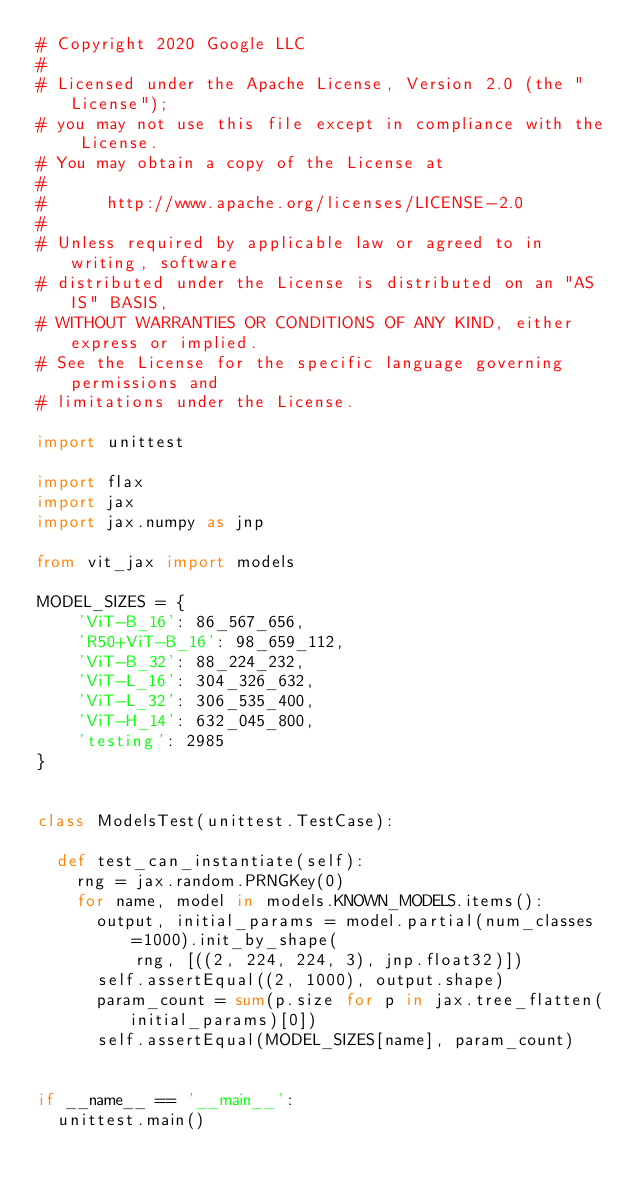<code> <loc_0><loc_0><loc_500><loc_500><_Python_># Copyright 2020 Google LLC
#
# Licensed under the Apache License, Version 2.0 (the "License");
# you may not use this file except in compliance with the License.
# You may obtain a copy of the License at
#
#      http://www.apache.org/licenses/LICENSE-2.0
#
# Unless required by applicable law or agreed to in writing, software
# distributed under the License is distributed on an "AS IS" BASIS,
# WITHOUT WARRANTIES OR CONDITIONS OF ANY KIND, either express or implied.
# See the License for the specific language governing permissions and
# limitations under the License.

import unittest

import flax
import jax
import jax.numpy as jnp

from vit_jax import models

MODEL_SIZES = {
    'ViT-B_16': 86_567_656,
    'R50+ViT-B_16': 98_659_112,
    'ViT-B_32': 88_224_232,
    'ViT-L_16': 304_326_632,
    'ViT-L_32': 306_535_400,
    'ViT-H_14': 632_045_800,
    'testing': 2985
}


class ModelsTest(unittest.TestCase):

  def test_can_instantiate(self):
    rng = jax.random.PRNGKey(0)
    for name, model in models.KNOWN_MODELS.items():
      output, initial_params = model.partial(num_classes=1000).init_by_shape(
          rng, [((2, 224, 224, 3), jnp.float32)])
      self.assertEqual((2, 1000), output.shape)
      param_count = sum(p.size for p in jax.tree_flatten(initial_params)[0])
      self.assertEqual(MODEL_SIZES[name], param_count)


if __name__ == '__main__':
  unittest.main()
</code> 